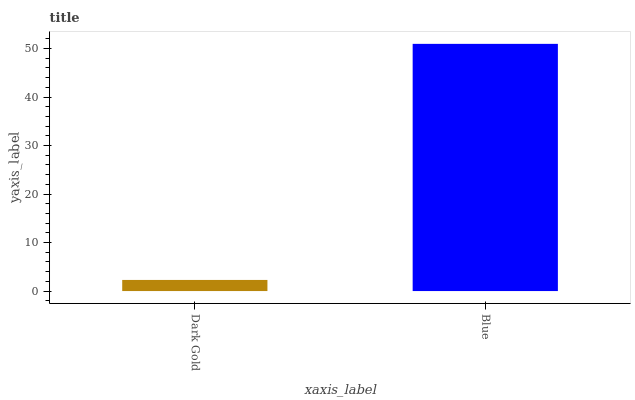Is Dark Gold the minimum?
Answer yes or no. Yes. Is Blue the maximum?
Answer yes or no. Yes. Is Blue the minimum?
Answer yes or no. No. Is Blue greater than Dark Gold?
Answer yes or no. Yes. Is Dark Gold less than Blue?
Answer yes or no. Yes. Is Dark Gold greater than Blue?
Answer yes or no. No. Is Blue less than Dark Gold?
Answer yes or no. No. Is Blue the high median?
Answer yes or no. Yes. Is Dark Gold the low median?
Answer yes or no. Yes. Is Dark Gold the high median?
Answer yes or no. No. Is Blue the low median?
Answer yes or no. No. 